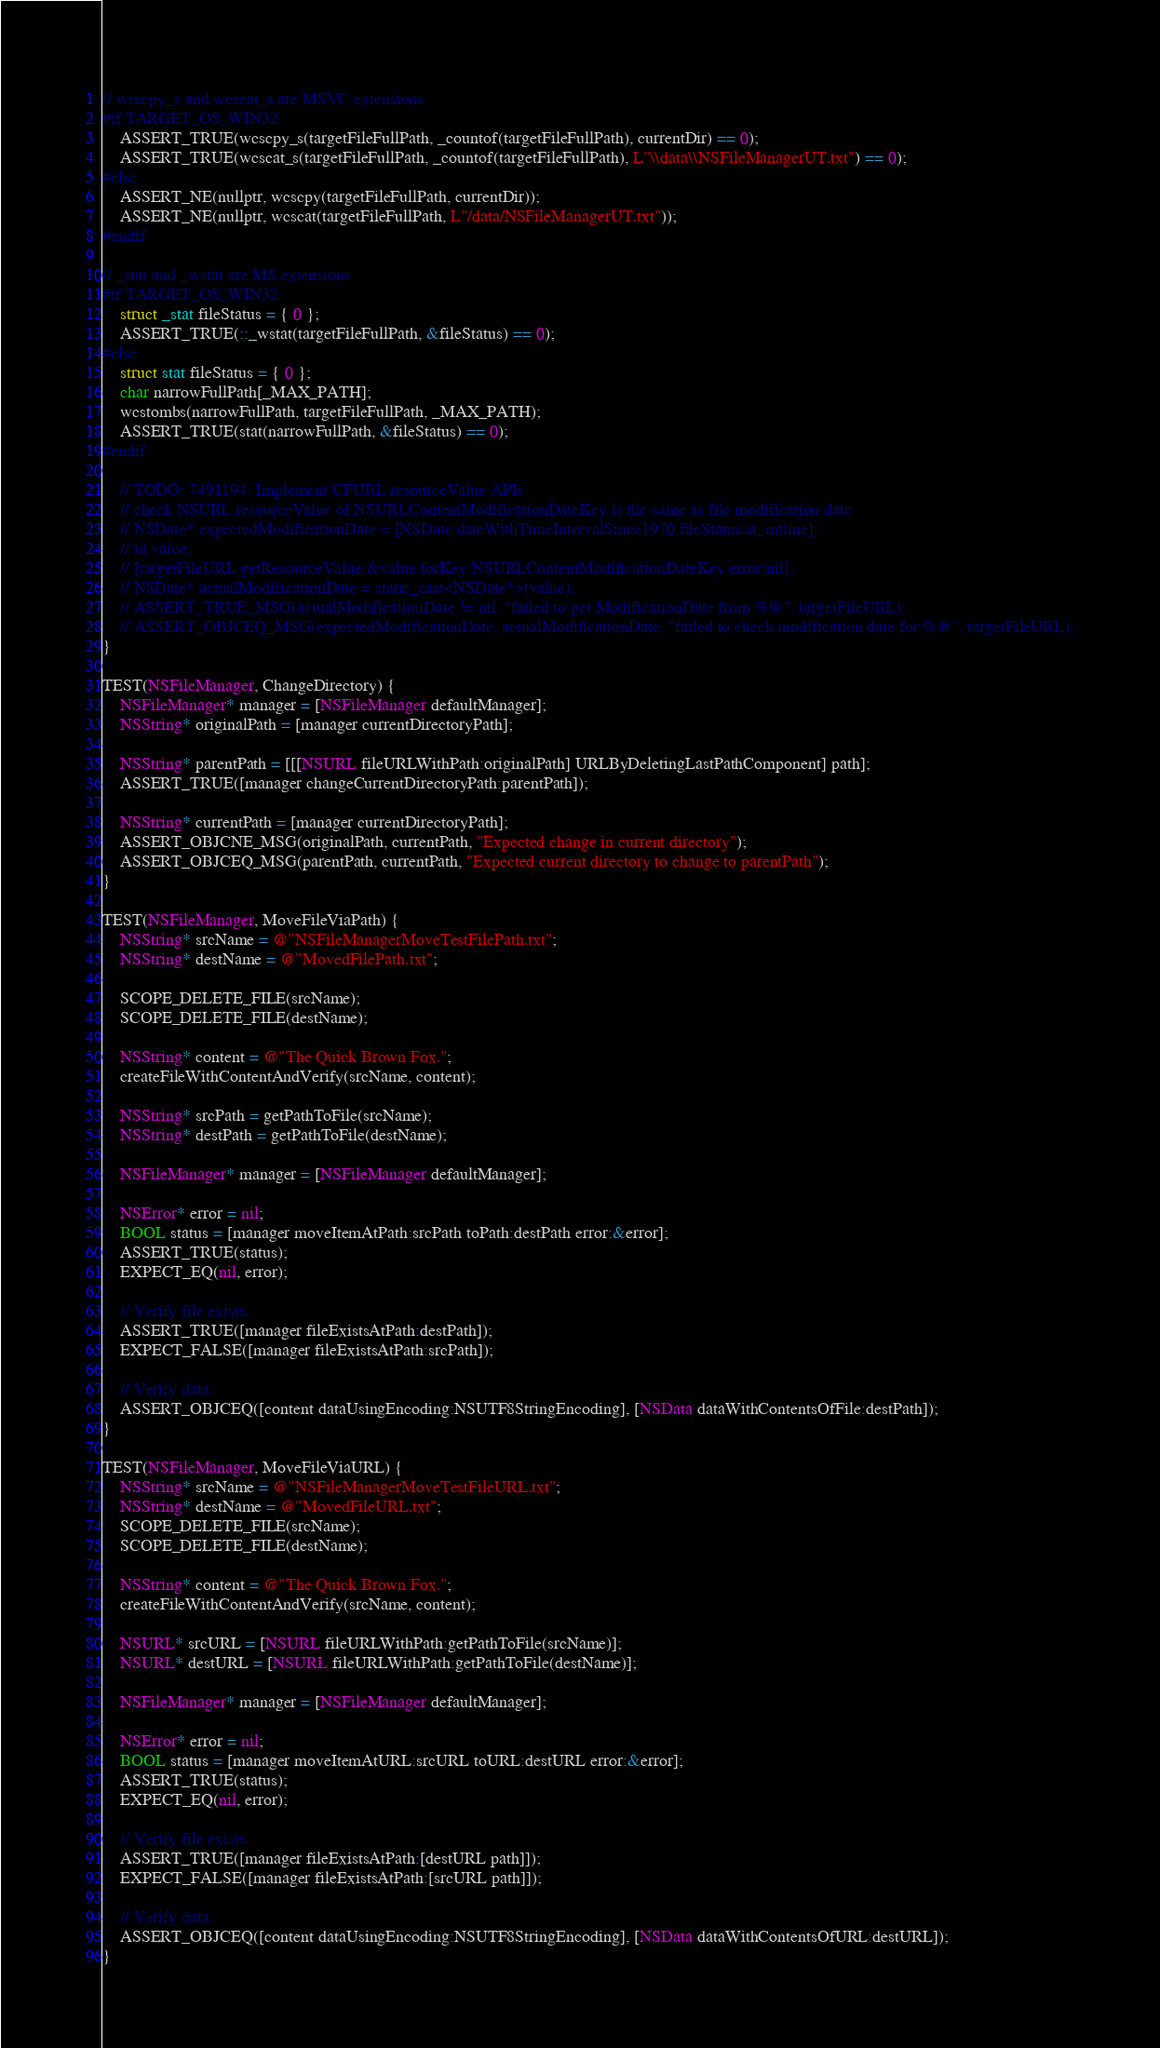<code> <loc_0><loc_0><loc_500><loc_500><_ObjectiveC_>// wcscpy_s and wcscat_s are MSVC extensions
#if TARGET_OS_WIN32
    ASSERT_TRUE(wcscpy_s(targetFileFullPath, _countof(targetFileFullPath), currentDir) == 0);
    ASSERT_TRUE(wcscat_s(targetFileFullPath, _countof(targetFileFullPath), L"\\data\\NSFileManagerUT.txt") == 0);
#else
    ASSERT_NE(nullptr, wcscpy(targetFileFullPath, currentDir));
    ASSERT_NE(nullptr, wcscat(targetFileFullPath, L"/data/NSFileManagerUT.txt"));
#endif

// _stat and _wstat are MS extensions
#if TARGET_OS_WIN32
    struct _stat fileStatus = { 0 };
    ASSERT_TRUE(::_wstat(targetFileFullPath, &fileStatus) == 0);
#else
    struct stat fileStatus = { 0 };
    char narrowFullPath[_MAX_PATH];
    wcstombs(narrowFullPath, targetFileFullPath, _MAX_PATH);
    ASSERT_TRUE(stat(narrowFullPath, &fileStatus) == 0);
#endif

    // TODO: 7491194: Implement CFURL resourceValue APIs
    // check NSURL resourceValue of NSURLContentModificationDateKey is the same as file modification date
    // NSDate* expectedModificationDate = [NSDate dateWithTimeIntervalSince1970:fileStatus.st_mtime];
    // id value;
    // [targetFileURL getResourceValue:&value forKey:NSURLContentModificationDateKey error:nil];
    // NSDate* actualModificationDate = static_cast<NSDate*>(value);
    // ASSERT_TRUE_MSG(actualModificationDate != nil, "failed to get ModificationDate from %@", targetFileURL);
    // ASSERT_OBJCEQ_MSG(expectedModificationDate, actualModificationDate, "failed to check modification date for %@", targetFileURL);
}

TEST(NSFileManager, ChangeDirectory) {
    NSFileManager* manager = [NSFileManager defaultManager];
    NSString* originalPath = [manager currentDirectoryPath];

    NSString* parentPath = [[[NSURL fileURLWithPath:originalPath] URLByDeletingLastPathComponent] path];
    ASSERT_TRUE([manager changeCurrentDirectoryPath:parentPath]);

    NSString* currentPath = [manager currentDirectoryPath];
    ASSERT_OBJCNE_MSG(originalPath, currentPath, "Expected change in current directory");
    ASSERT_OBJCEQ_MSG(parentPath, currentPath, "Expected current directory to change to parentPath");
}

TEST(NSFileManager, MoveFileViaPath) {
    NSString* srcName = @"NSFileManagerMoveTestFilePath.txt";
    NSString* destName = @"MovedFilePath.txt";

    SCOPE_DELETE_FILE(srcName);
    SCOPE_DELETE_FILE(destName);

    NSString* content = @"The Quick Brown Fox.";
    createFileWithContentAndVerify(srcName, content);

    NSString* srcPath = getPathToFile(srcName);
    NSString* destPath = getPathToFile(destName);

    NSFileManager* manager = [NSFileManager defaultManager];

    NSError* error = nil;
    BOOL status = [manager moveItemAtPath:srcPath toPath:destPath error:&error];
    ASSERT_TRUE(status);
    EXPECT_EQ(nil, error);

    // Verify file exists.
    ASSERT_TRUE([manager fileExistsAtPath:destPath]);
    EXPECT_FALSE([manager fileExistsAtPath:srcPath]);

    // Verify data.
    ASSERT_OBJCEQ([content dataUsingEncoding:NSUTF8StringEncoding], [NSData dataWithContentsOfFile:destPath]);
}

TEST(NSFileManager, MoveFileViaURL) {
    NSString* srcName = @"NSFileManagerMoveTestFileURL.txt";
    NSString* destName = @"MovedFileURL.txt";
    SCOPE_DELETE_FILE(srcName);
    SCOPE_DELETE_FILE(destName);

    NSString* content = @"The Quick Brown Fox.";
    createFileWithContentAndVerify(srcName, content);

    NSURL* srcURL = [NSURL fileURLWithPath:getPathToFile(srcName)];
    NSURL* destURL = [NSURL fileURLWithPath:getPathToFile(destName)];

    NSFileManager* manager = [NSFileManager defaultManager];

    NSError* error = nil;
    BOOL status = [manager moveItemAtURL:srcURL toURL:destURL error:&error];
    ASSERT_TRUE(status);
    EXPECT_EQ(nil, error);

    // Verify file exists.
    ASSERT_TRUE([manager fileExistsAtPath:[destURL path]]);
    EXPECT_FALSE([manager fileExistsAtPath:[srcURL path]]);

    // Verify data.
    ASSERT_OBJCEQ([content dataUsingEncoding:NSUTF8StringEncoding], [NSData dataWithContentsOfURL:destURL]);
}
</code> 